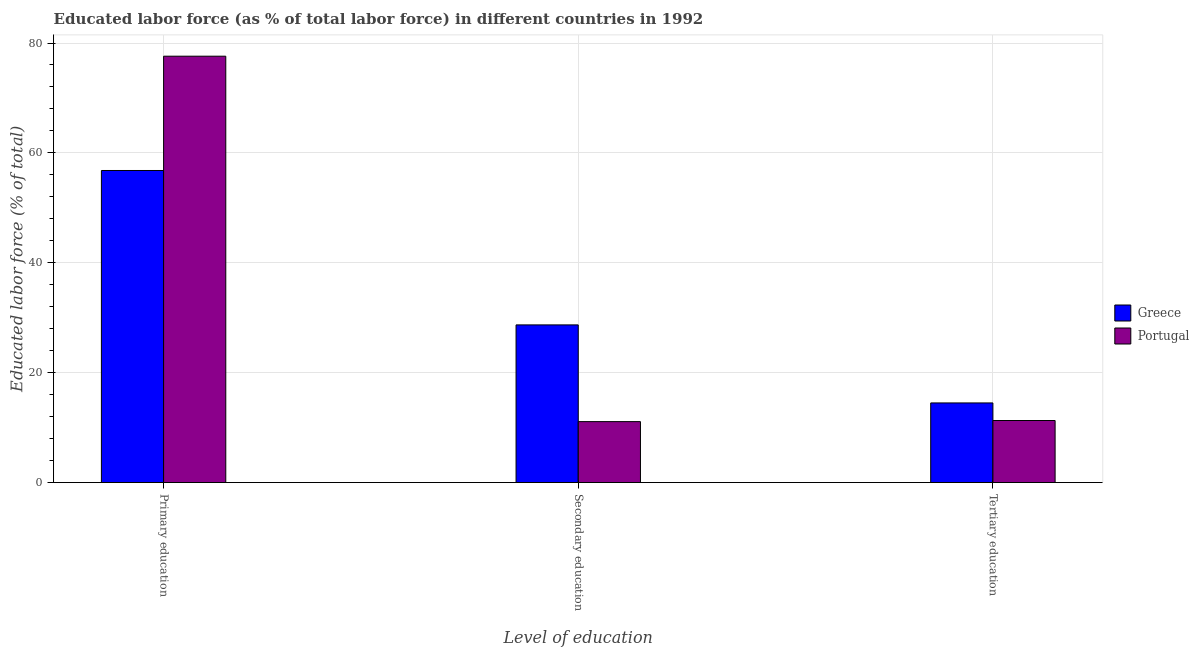Are the number of bars per tick equal to the number of legend labels?
Your response must be concise. Yes. Are the number of bars on each tick of the X-axis equal?
Keep it short and to the point. Yes. How many bars are there on the 2nd tick from the right?
Provide a succinct answer. 2. What is the label of the 3rd group of bars from the left?
Your answer should be compact. Tertiary education. What is the percentage of labor force who received tertiary education in Portugal?
Make the answer very short. 11.3. Across all countries, what is the maximum percentage of labor force who received secondary education?
Give a very brief answer. 28.7. Across all countries, what is the minimum percentage of labor force who received secondary education?
Give a very brief answer. 11.1. In which country was the percentage of labor force who received primary education minimum?
Ensure brevity in your answer.  Greece. What is the total percentage of labor force who received tertiary education in the graph?
Provide a short and direct response. 25.8. What is the difference between the percentage of labor force who received secondary education in Portugal and that in Greece?
Your answer should be very brief. -17.6. What is the difference between the percentage of labor force who received secondary education in Greece and the percentage of labor force who received primary education in Portugal?
Keep it short and to the point. -48.9. What is the average percentage of labor force who received secondary education per country?
Your answer should be compact. 19.9. What is the difference between the percentage of labor force who received primary education and percentage of labor force who received tertiary education in Portugal?
Ensure brevity in your answer.  66.3. In how many countries, is the percentage of labor force who received tertiary education greater than 76 %?
Give a very brief answer. 0. What is the ratio of the percentage of labor force who received secondary education in Greece to that in Portugal?
Offer a very short reply. 2.59. What is the difference between the highest and the second highest percentage of labor force who received primary education?
Give a very brief answer. 20.8. What is the difference between the highest and the lowest percentage of labor force who received tertiary education?
Provide a succinct answer. 3.2. Is the sum of the percentage of labor force who received secondary education in Greece and Portugal greater than the maximum percentage of labor force who received primary education across all countries?
Ensure brevity in your answer.  No. Are the values on the major ticks of Y-axis written in scientific E-notation?
Your answer should be compact. No. Where does the legend appear in the graph?
Provide a short and direct response. Center right. How many legend labels are there?
Offer a terse response. 2. What is the title of the graph?
Give a very brief answer. Educated labor force (as % of total labor force) in different countries in 1992. What is the label or title of the X-axis?
Your answer should be very brief. Level of education. What is the label or title of the Y-axis?
Keep it short and to the point. Educated labor force (% of total). What is the Educated labor force (% of total) in Greece in Primary education?
Ensure brevity in your answer.  56.8. What is the Educated labor force (% of total) in Portugal in Primary education?
Offer a very short reply. 77.6. What is the Educated labor force (% of total) of Greece in Secondary education?
Ensure brevity in your answer.  28.7. What is the Educated labor force (% of total) of Portugal in Secondary education?
Provide a succinct answer. 11.1. What is the Educated labor force (% of total) in Portugal in Tertiary education?
Your answer should be compact. 11.3. Across all Level of education, what is the maximum Educated labor force (% of total) in Greece?
Ensure brevity in your answer.  56.8. Across all Level of education, what is the maximum Educated labor force (% of total) in Portugal?
Your answer should be very brief. 77.6. Across all Level of education, what is the minimum Educated labor force (% of total) of Portugal?
Keep it short and to the point. 11.1. What is the total Educated labor force (% of total) of Greece in the graph?
Your answer should be very brief. 100. What is the total Educated labor force (% of total) in Portugal in the graph?
Your answer should be compact. 100. What is the difference between the Educated labor force (% of total) of Greece in Primary education and that in Secondary education?
Your answer should be compact. 28.1. What is the difference between the Educated labor force (% of total) of Portugal in Primary education and that in Secondary education?
Your response must be concise. 66.5. What is the difference between the Educated labor force (% of total) of Greece in Primary education and that in Tertiary education?
Keep it short and to the point. 42.3. What is the difference between the Educated labor force (% of total) in Portugal in Primary education and that in Tertiary education?
Your answer should be compact. 66.3. What is the difference between the Educated labor force (% of total) of Greece in Secondary education and that in Tertiary education?
Provide a short and direct response. 14.2. What is the difference between the Educated labor force (% of total) in Portugal in Secondary education and that in Tertiary education?
Your answer should be compact. -0.2. What is the difference between the Educated labor force (% of total) in Greece in Primary education and the Educated labor force (% of total) in Portugal in Secondary education?
Provide a succinct answer. 45.7. What is the difference between the Educated labor force (% of total) in Greece in Primary education and the Educated labor force (% of total) in Portugal in Tertiary education?
Your answer should be very brief. 45.5. What is the average Educated labor force (% of total) in Greece per Level of education?
Provide a succinct answer. 33.33. What is the average Educated labor force (% of total) of Portugal per Level of education?
Make the answer very short. 33.33. What is the difference between the Educated labor force (% of total) in Greece and Educated labor force (% of total) in Portugal in Primary education?
Your response must be concise. -20.8. What is the ratio of the Educated labor force (% of total) in Greece in Primary education to that in Secondary education?
Your answer should be very brief. 1.98. What is the ratio of the Educated labor force (% of total) in Portugal in Primary education to that in Secondary education?
Offer a terse response. 6.99. What is the ratio of the Educated labor force (% of total) of Greece in Primary education to that in Tertiary education?
Ensure brevity in your answer.  3.92. What is the ratio of the Educated labor force (% of total) of Portugal in Primary education to that in Tertiary education?
Provide a succinct answer. 6.87. What is the ratio of the Educated labor force (% of total) in Greece in Secondary education to that in Tertiary education?
Your answer should be compact. 1.98. What is the ratio of the Educated labor force (% of total) in Portugal in Secondary education to that in Tertiary education?
Your answer should be compact. 0.98. What is the difference between the highest and the second highest Educated labor force (% of total) of Greece?
Offer a very short reply. 28.1. What is the difference between the highest and the second highest Educated labor force (% of total) in Portugal?
Offer a terse response. 66.3. What is the difference between the highest and the lowest Educated labor force (% of total) of Greece?
Make the answer very short. 42.3. What is the difference between the highest and the lowest Educated labor force (% of total) of Portugal?
Ensure brevity in your answer.  66.5. 